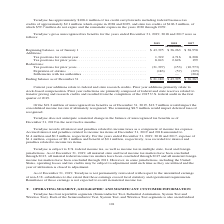According to Teradyne's financial document, What do Prior year additions primarily relate to? stock-based compensation. The document states: "credits. Prior year additions primarily relate to stock-based compensation. Prior year reductions are primarily composed of federal and state reserves..." Also, What do Current year additions relate to? federal and state research credits. The document states: "Current year additions relate to federal and state research credits. Prior year additions primarily relate to stock-based compensation. Prior year red..." Also, In which years was Teradyne’s gross unrecognized tax benefits calculated? The document contains multiple relevant values: 2019, 2018, 2017. From the document: "2019 2018 2017 2019 2018 2017 2019 2018 2017..." Additionally, In which year was the Ending balance, as of December 31 the largest? According to the financial document, 2018. The relevant text states: "2019 2018 2017..." Also, can you calculate: What was the change in Beginning balance, as of January 1 in 2019 from 2018? Based on the calculation: 43,395-36,263, the result is 7132 (in thousands). This is based on the information: ") Beginning balance, as of January 1 . $ 43,395 $ 36,263 $ 38,958 Additions: Tax positions for current year . 1,322 4,716 8,208 Tax positions for prior year thousands) Beginning balance, as of January..." The key data points involved are: 36,263, 43,395. Also, can you calculate: What was the percentage change in Beginning balance, as of January 1 in 2019 from 2018? To answer this question, I need to perform calculations using the financial data. The calculation is: (43,395-36,263)/36,263, which equals 19.67 (percentage). This is based on the information: ") Beginning balance, as of January 1 . $ 43,395 $ 36,263 $ 38,958 Additions: Tax positions for current year . 1,322 4,716 8,208 Tax positions for prior year thousands) Beginning balance, as of January..." The key data points involved are: 36,263, 43,395. 